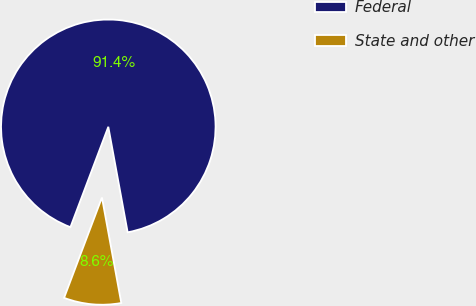<chart> <loc_0><loc_0><loc_500><loc_500><pie_chart><fcel>Federal<fcel>State and other<nl><fcel>91.37%<fcel>8.63%<nl></chart> 